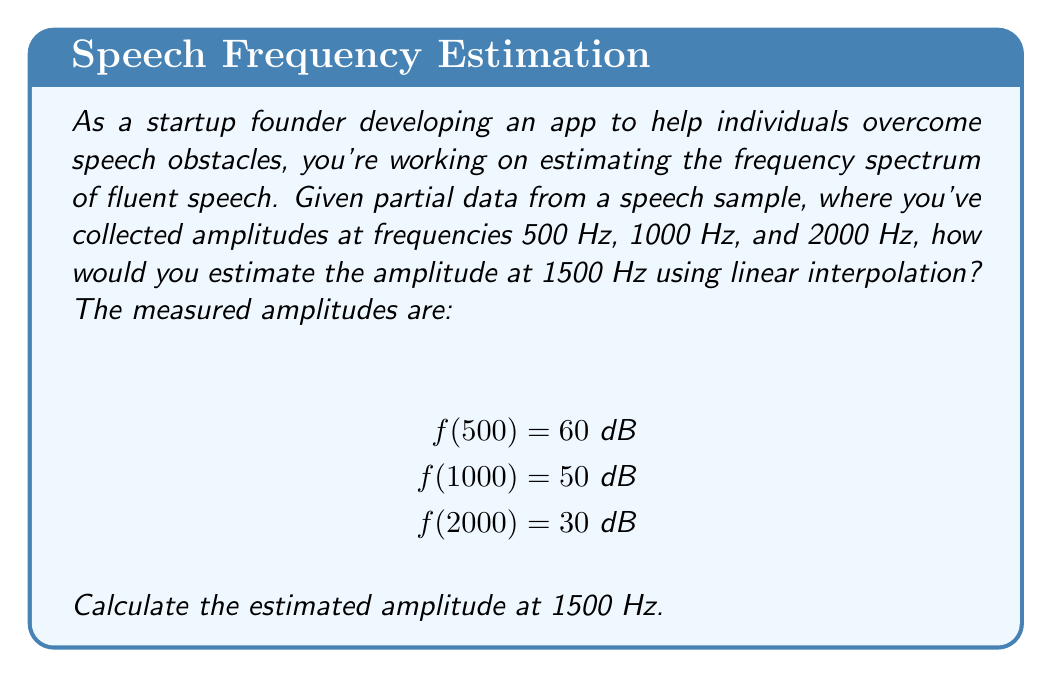Show me your answer to this math problem. To estimate the amplitude at 1500 Hz using linear interpolation, we'll follow these steps:

1) Linear interpolation uses the formula:
   $$f(x) = f(x_1) + \frac{f(x_2) - f(x_1)}{x_2 - x_1}(x - x_1)$$
   where $x$ is the point we're estimating, and $(x_1, f(x_1))$ and $(x_2, f(x_2))$ are the known points.

2) For 1500 Hz, we'll use the known points at 1000 Hz and 2000 Hz:
   $x_1 = 1000$, $f(x_1) = 50$ dB
   $x_2 = 2000$, $f(x_2) = 30$ dB
   $x = 1500$

3) Plugging these values into the formula:
   $$f(1500) = 50 + \frac{30 - 50}{2000 - 1000}(1500 - 1000)$$

4) Simplify:
   $$f(1500) = 50 + \frac{-20}{1000}(500)$$
   $$f(1500) = 50 + (-20)(0.5)$$
   $$f(1500) = 50 - 10 = 40$$

Therefore, the estimated amplitude at 1500 Hz is 40 dB.
Answer: 40 dB 